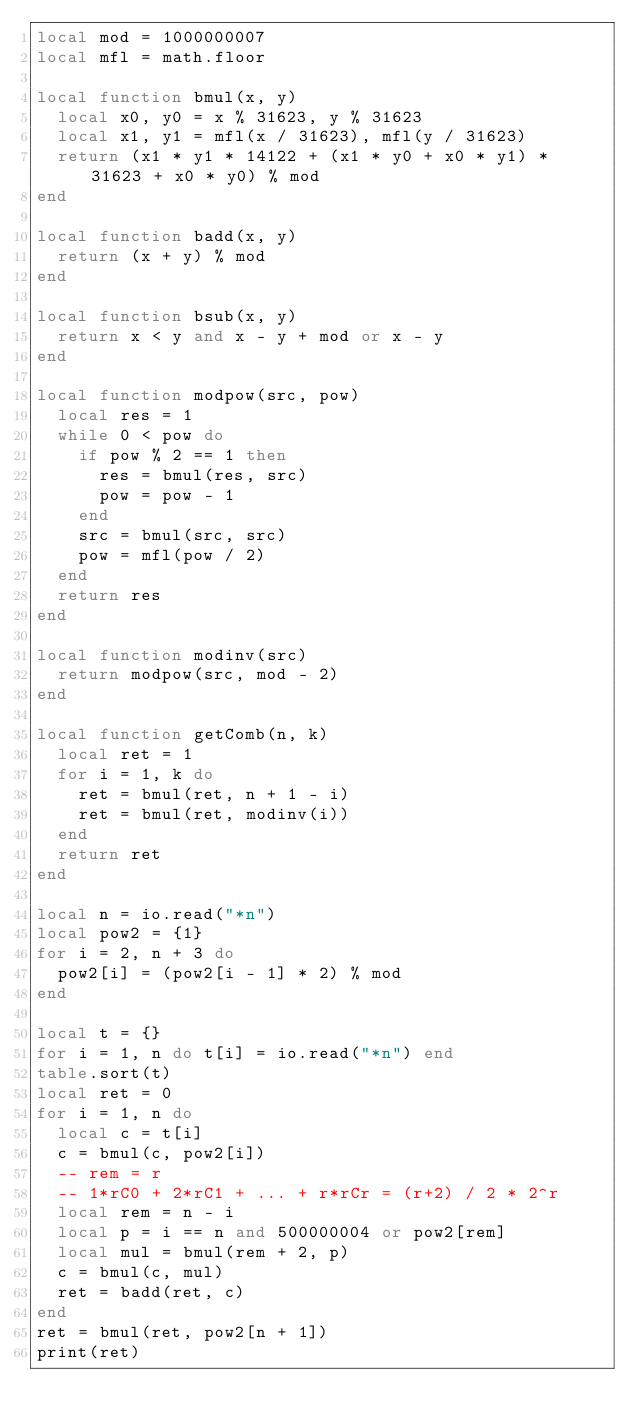<code> <loc_0><loc_0><loc_500><loc_500><_Lua_>local mod = 1000000007
local mfl = math.floor

local function bmul(x, y)
  local x0, y0 = x % 31623, y % 31623
  local x1, y1 = mfl(x / 31623), mfl(y / 31623)
  return (x1 * y1 * 14122 + (x1 * y0 + x0 * y1) * 31623 + x0 * y0) % mod
end

local function badd(x, y)
  return (x + y) % mod
end

local function bsub(x, y)
  return x < y and x - y + mod or x - y
end

local function modpow(src, pow)
  local res = 1
  while 0 < pow do
    if pow % 2 == 1 then
      res = bmul(res, src)
      pow = pow - 1
    end
    src = bmul(src, src)
    pow = mfl(pow / 2)
  end
  return res
end

local function modinv(src)
  return modpow(src, mod - 2)
end

local function getComb(n, k)
  local ret = 1
  for i = 1, k do
    ret = bmul(ret, n + 1 - i)
    ret = bmul(ret, modinv(i))
  end
  return ret
end

local n = io.read("*n")
local pow2 = {1}
for i = 2, n + 3 do
  pow2[i] = (pow2[i - 1] * 2) % mod
end

local t = {}
for i = 1, n do t[i] = io.read("*n") end
table.sort(t)
local ret = 0
for i = 1, n do
  local c = t[i]
  c = bmul(c, pow2[i])
  -- rem = r
  -- 1*rC0 + 2*rC1 + ... + r*rCr = (r+2) / 2 * 2^r
  local rem = n - i
  local p = i == n and 500000004 or pow2[rem]
  local mul = bmul(rem + 2, p)
  c = bmul(c, mul)
  ret = badd(ret, c)
end
ret = bmul(ret, pow2[n + 1])
print(ret)
</code> 